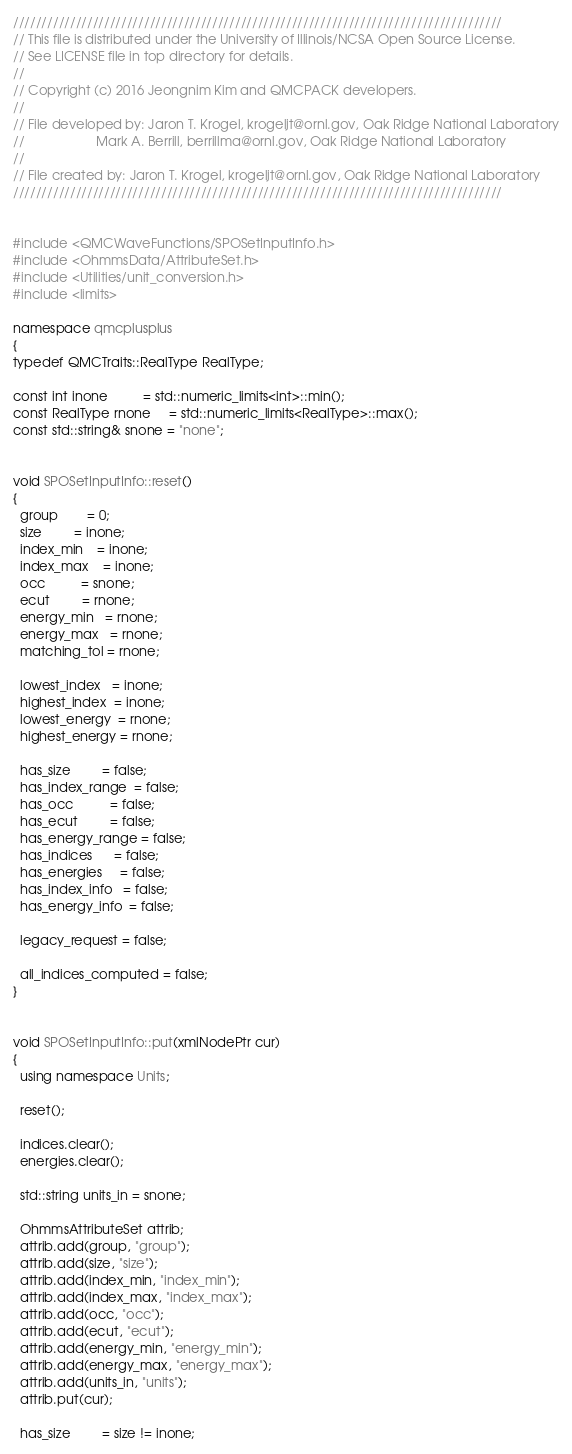<code> <loc_0><loc_0><loc_500><loc_500><_C++_>//////////////////////////////////////////////////////////////////////////////////////
// This file is distributed under the University of Illinois/NCSA Open Source License.
// See LICENSE file in top directory for details.
//
// Copyright (c) 2016 Jeongnim Kim and QMCPACK developers.
//
// File developed by: Jaron T. Krogel, krogeljt@ornl.gov, Oak Ridge National Laboratory
//                    Mark A. Berrill, berrillma@ornl.gov, Oak Ridge National Laboratory
//
// File created by: Jaron T. Krogel, krogeljt@ornl.gov, Oak Ridge National Laboratory
//////////////////////////////////////////////////////////////////////////////////////


#include <QMCWaveFunctions/SPOSetInputInfo.h>
#include <OhmmsData/AttributeSet.h>
#include <Utilities/unit_conversion.h>
#include <limits>

namespace qmcplusplus
{
typedef QMCTraits::RealType RealType;

const int inone          = std::numeric_limits<int>::min();
const RealType rnone     = std::numeric_limits<RealType>::max();
const std::string& snone = "none";


void SPOSetInputInfo::reset()
{
  group        = 0;
  size         = inone;
  index_min    = inone;
  index_max    = inone;
  occ          = snone;
  ecut         = rnone;
  energy_min   = rnone;
  energy_max   = rnone;
  matching_tol = rnone;

  lowest_index   = inone;
  highest_index  = inone;
  lowest_energy  = rnone;
  highest_energy = rnone;

  has_size         = false;
  has_index_range  = false;
  has_occ          = false;
  has_ecut         = false;
  has_energy_range = false;
  has_indices      = false;
  has_energies     = false;
  has_index_info   = false;
  has_energy_info  = false;

  legacy_request = false;

  all_indices_computed = false;
}


void SPOSetInputInfo::put(xmlNodePtr cur)
{
  using namespace Units;

  reset();

  indices.clear();
  energies.clear();

  std::string units_in = snone;

  OhmmsAttributeSet attrib;
  attrib.add(group, "group");
  attrib.add(size, "size");
  attrib.add(index_min, "index_min");
  attrib.add(index_max, "index_max");
  attrib.add(occ, "occ");
  attrib.add(ecut, "ecut");
  attrib.add(energy_min, "energy_min");
  attrib.add(energy_max, "energy_max");
  attrib.add(units_in, "units");
  attrib.put(cur);

  has_size         = size != inone;</code> 